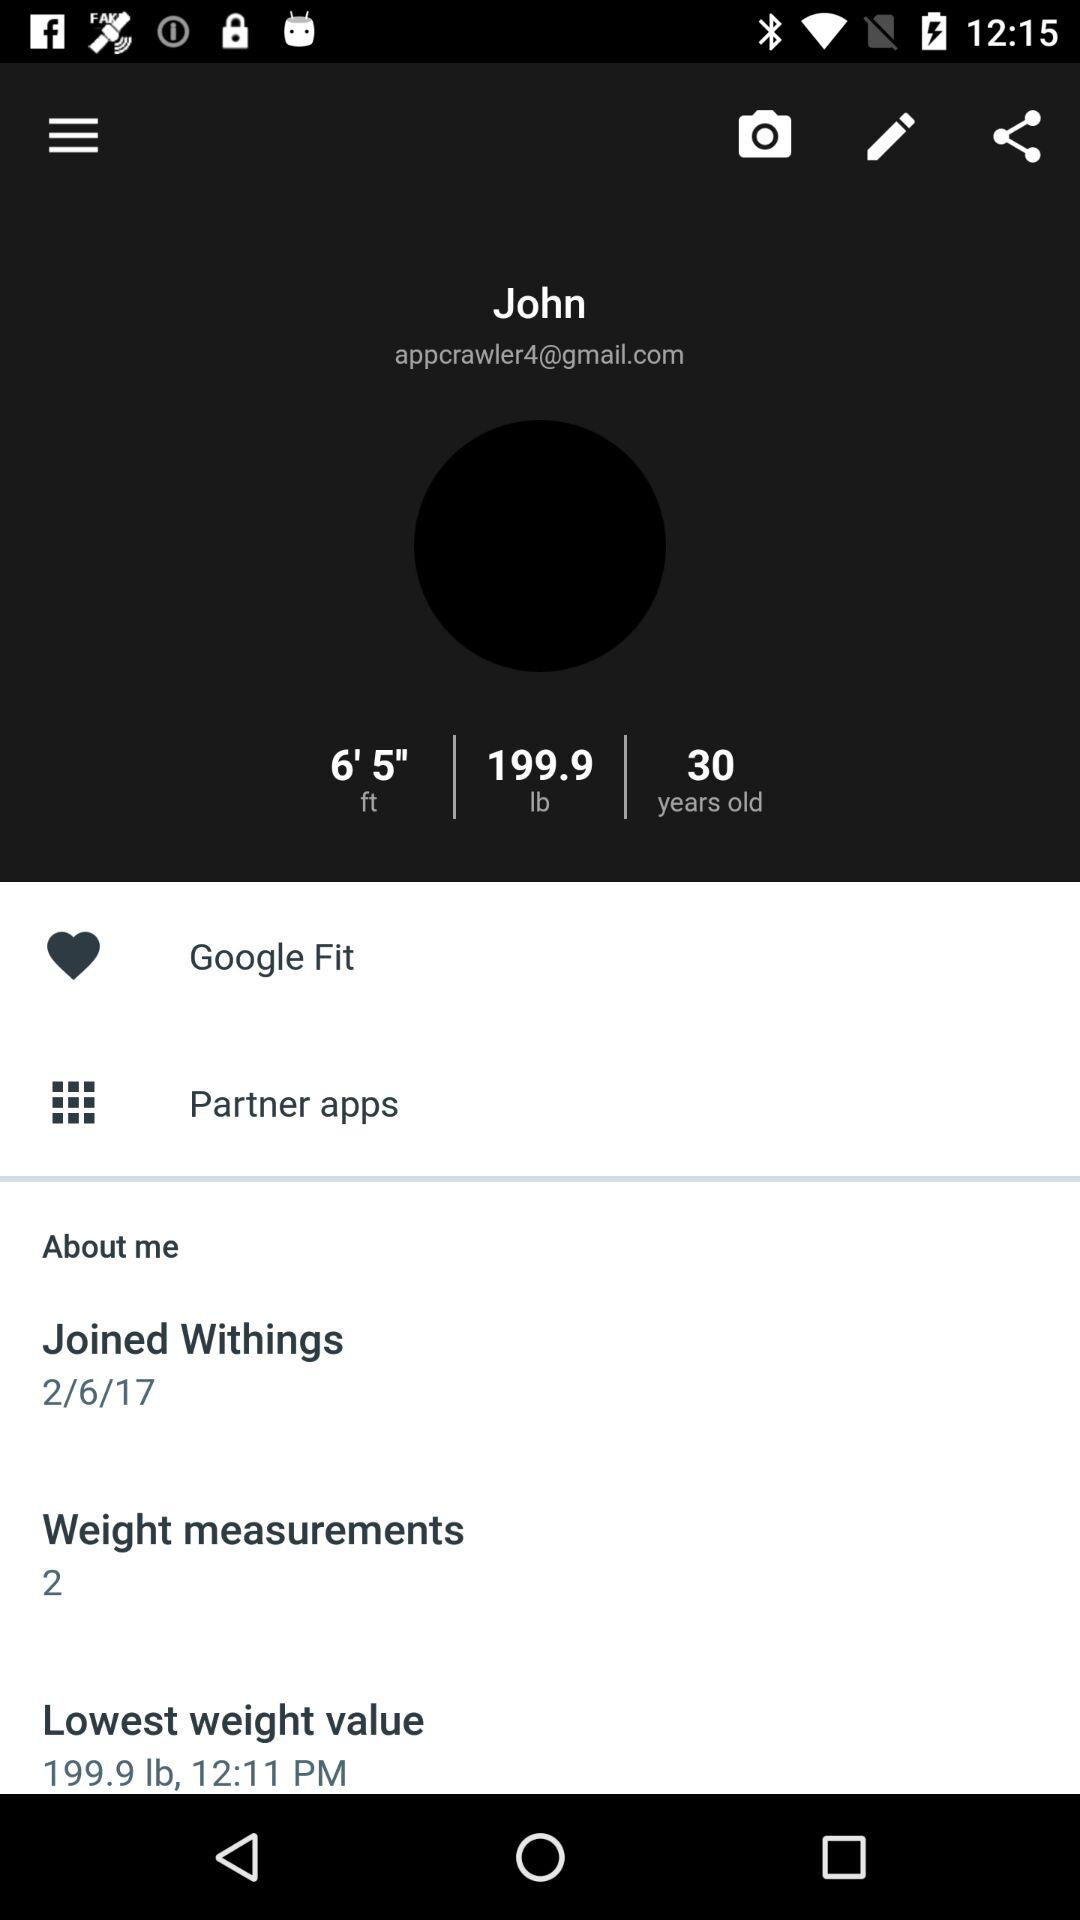What's the lowest weight value? The lowest weight value is 199.9 lb. 